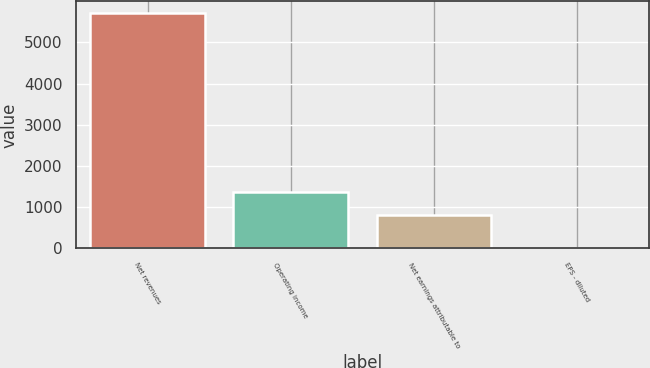Convert chart to OTSL. <chart><loc_0><loc_0><loc_500><loc_500><bar_chart><fcel>Net revenues<fcel>Operating income<fcel>Net earnings attributable to<fcel>EPS - diluted<nl><fcel>5711.2<fcel>1372.07<fcel>801<fcel>0.54<nl></chart> 